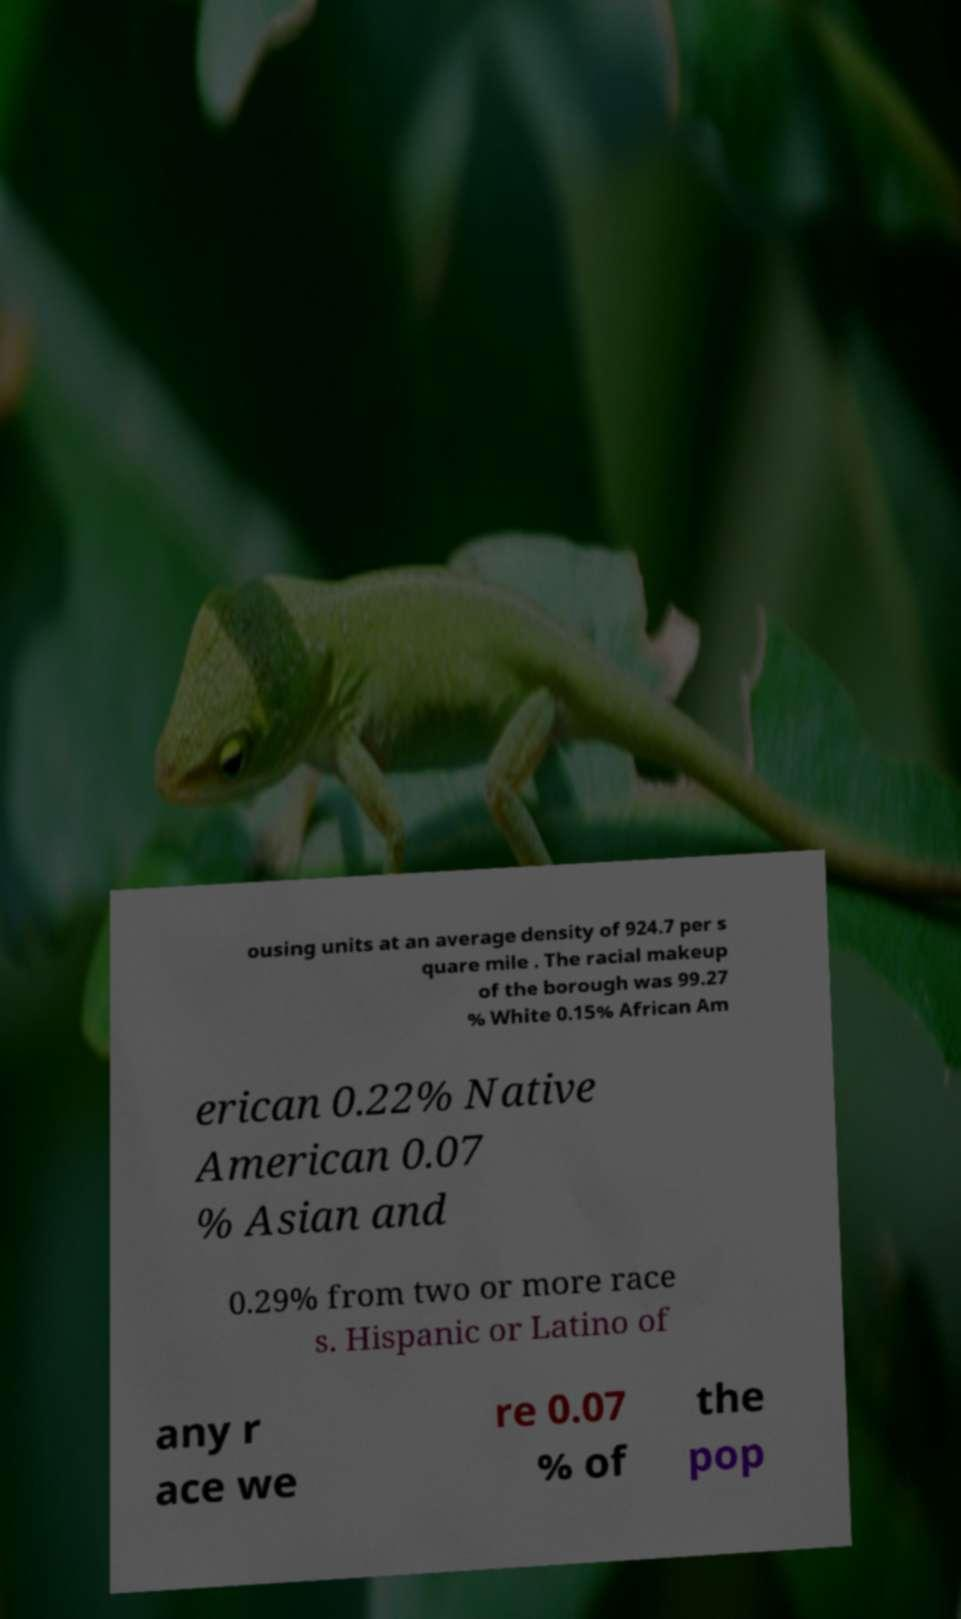Can you accurately transcribe the text from the provided image for me? ousing units at an average density of 924.7 per s quare mile . The racial makeup of the borough was 99.27 % White 0.15% African Am erican 0.22% Native American 0.07 % Asian and 0.29% from two or more race s. Hispanic or Latino of any r ace we re 0.07 % of the pop 